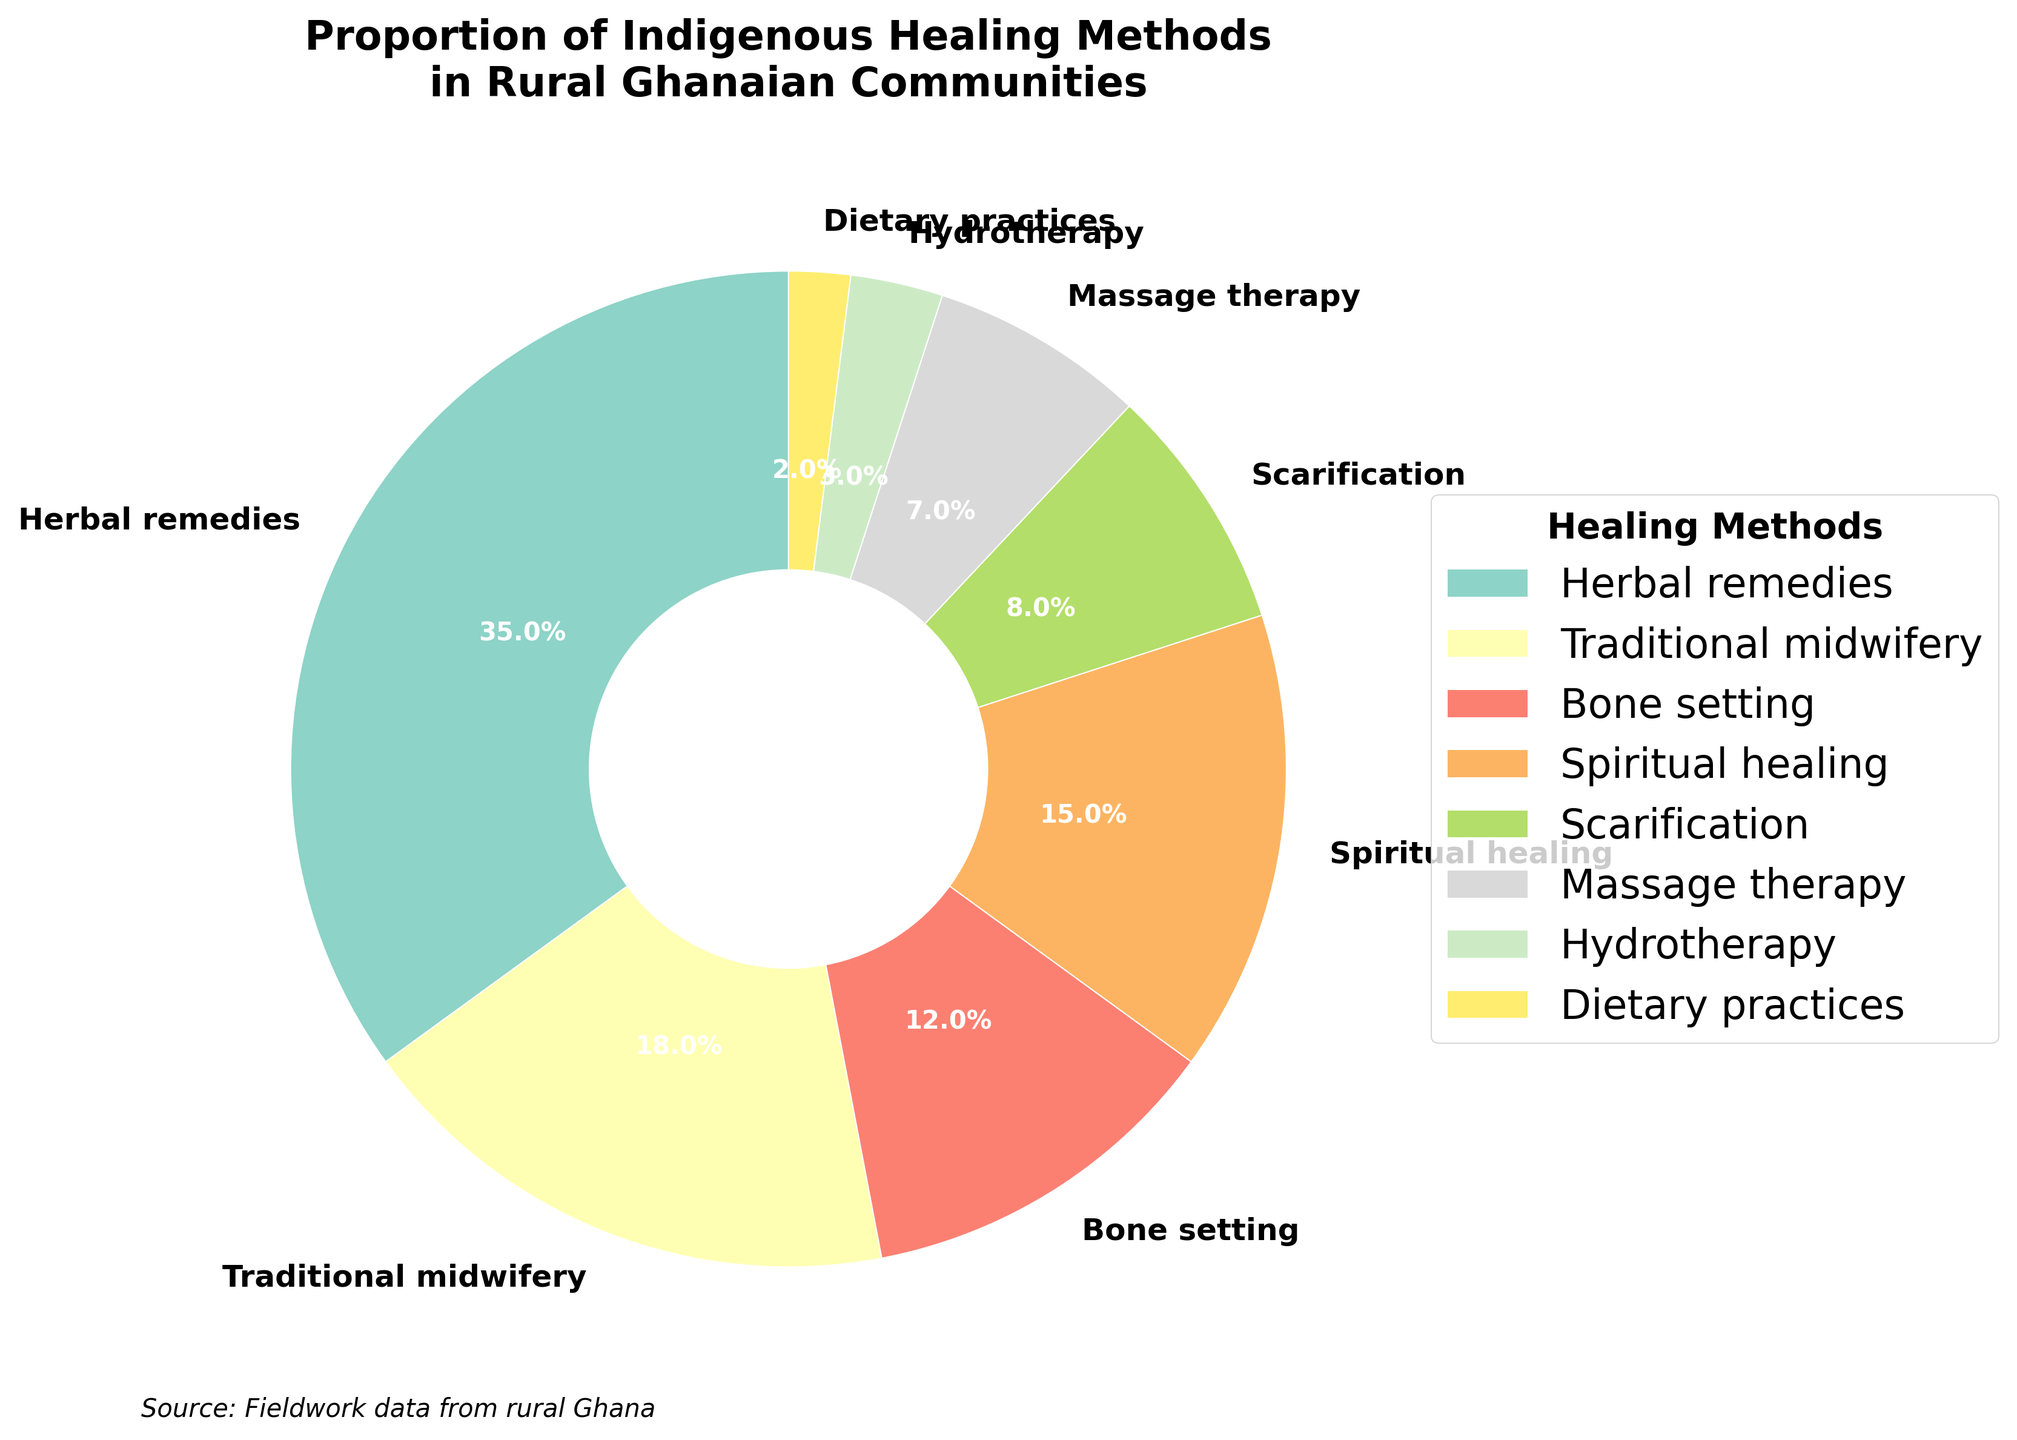What is the most commonly used indigenous healing method in rural Ghanaian communities? The figure titles and the largest pie wedge indicate that Herbal Remedies is the most commonly used method, occupying the largest percentage share.
Answer: Herbal Remedies What two methods combined account for more than 50% of the healing methods used? Add the percentages of different methods. Herbal Remedies (35%) and Traditional Midwifery (18%) together make 53%, which is more than 50%.
Answer: Herbal Remedies and Traditional Midwifery Which method is more commonly used: Bone Setting or Massage Therapy? Compare the slices labeled Bone Setting (12%) and Massage Therapy (7%) to see which has a larger percentage.
Answer: Bone Setting What proportion of the chart is occupied by Spiritual Healing and Scarification together? Add the percentages of Spiritual Healing (15%) and Scarification (8%) to get their combined proportion.
Answer: 23% How does the use of Scarification compare to the use of Dietary Practices? Check the percentages of Scarification (8%) and Dietary Practices (2%) and note that Scarification is higher.
Answer: Scarification is more commonly used Which healing method has the smallest representation in the pie chart? Identify the smallest wedge in the pie chart, labeled with its percentage.
Answer: Dietary Practices By roughly how much does the proportion of Herbal Remedies exceed that of Spiritual Healing? Subtract the Spiritual Healing proportion (15%) from the Herbal Remedies proportion (35%).
Answer: 20% Which methods have a proportion greater than 10%? Check the pie slices for methods that exceed 10%: Herbal Remedies (35%), Traditional Midwifery (18%), Bone Setting (12%), and Spiritual Healing (15%).
Answer: Herbal Remedies, Traditional Midwifery, Bone Setting, Spiritual Healing If you were to sum the percentages of Bone Setting, Scarification, and Massage Therapy, what would the total be? Add the percentages: Bone Setting (12%) + Scarification (8%) + Massage Therapy (7%).
Answer: 27% Which has a greater percentage: Hydrotherapy or Massage Therapy? Compare Hydrotherapy (3%) and Massage Therapy (7%) and note the larger percent.
Answer: Massage Therapy 